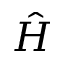Convert formula to latex. <formula><loc_0><loc_0><loc_500><loc_500>\hat { H }</formula> 